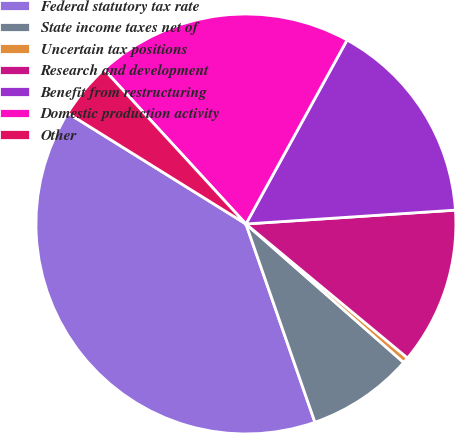Convert chart to OTSL. <chart><loc_0><loc_0><loc_500><loc_500><pie_chart><fcel>Federal statutory tax rate<fcel>State income taxes net of<fcel>Uncertain tax positions<fcel>Research and development<fcel>Benefit from restructuring<fcel>Domestic production activity<fcel>Other<nl><fcel>39.19%<fcel>8.2%<fcel>0.45%<fcel>12.07%<fcel>15.95%<fcel>19.82%<fcel>4.32%<nl></chart> 